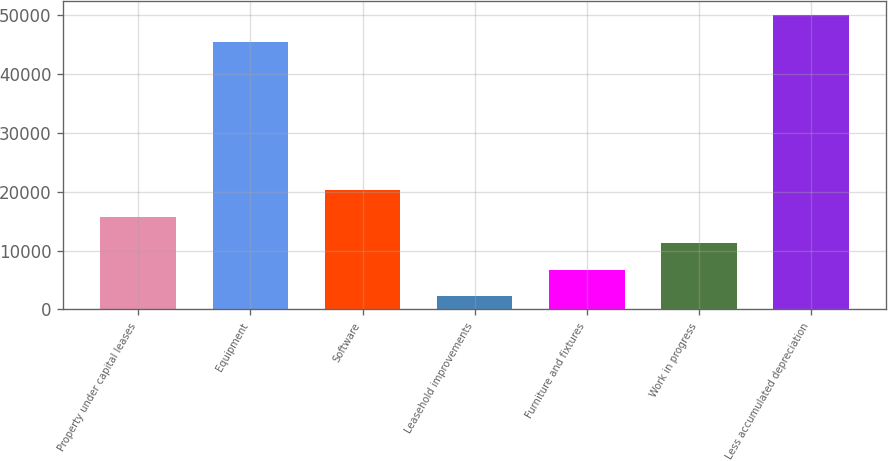<chart> <loc_0><loc_0><loc_500><loc_500><bar_chart><fcel>Property under capital leases<fcel>Equipment<fcel>Software<fcel>Leasehold improvements<fcel>Furniture and fixtures<fcel>Work in progress<fcel>Less accumulated depreciation<nl><fcel>15787.4<fcel>45454<fcel>20380<fcel>2273<fcel>6777.8<fcel>11282.6<fcel>49958.8<nl></chart> 